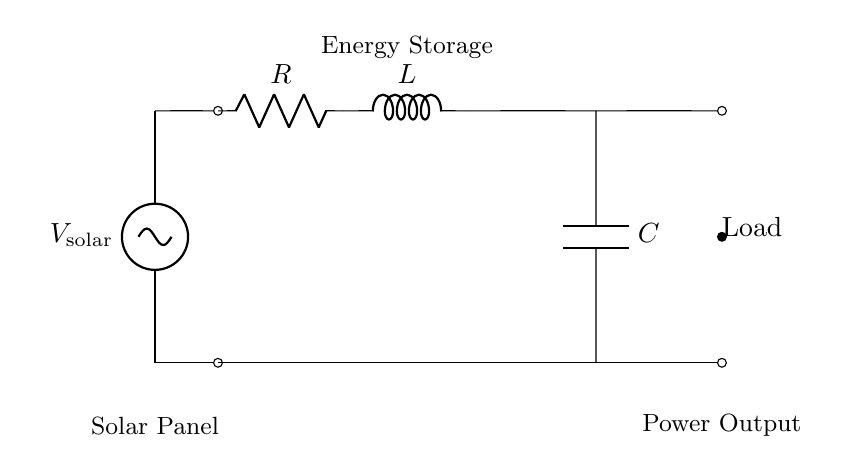What is the voltage source in this circuit? The voltage source indicated in the circuit is labeled as "V_solar". It represents the solar panel that supplies power to the circuit.
Answer: V_solar What component is used for energy storage? The component performing energy storage in this circuit is the capacitor, represented by "C". Capacitors are used to store and release electrical energy in electrical circuits.
Answer: C What components are connected in series? The resistor "R", inductor "L", and capacitor "C" are connected in series along the top path of the circuit. Each component connects directly to the next without any branches in between.
Answer: R, L, C What is the role of the inductor "L" in this circuit? The inductor "L" primarily contributes to energy storage in a magnetic field when current flows through it. It also helps in managing the timing of energy release to the load in conjunction with the capacitor.
Answer: Energy storage What is the measured output of the circuit? The output of the circuit is represented by the load which is depicted at the end of the circuit path, denoted simply as "Load". This signifies the destination for the stored energy being utilized.
Answer: Load What happens to current when the capacitor "C" discharges? When capacitor "C" discharges, it releases stored electrical energy into the load, thus providing current to it. This process allows the energy accumulated during the solar panel's operation to be delivered effectively when needed.
Answer: Current flows to Load 